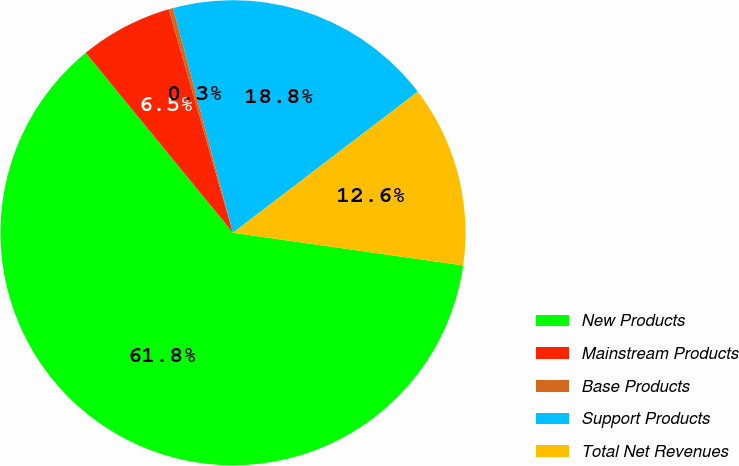Convert chart to OTSL. <chart><loc_0><loc_0><loc_500><loc_500><pie_chart><fcel>New Products<fcel>Mainstream Products<fcel>Base Products<fcel>Support Products<fcel>Total Net Revenues<nl><fcel>61.84%<fcel>6.46%<fcel>0.31%<fcel>18.77%<fcel>12.62%<nl></chart> 